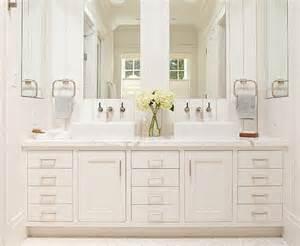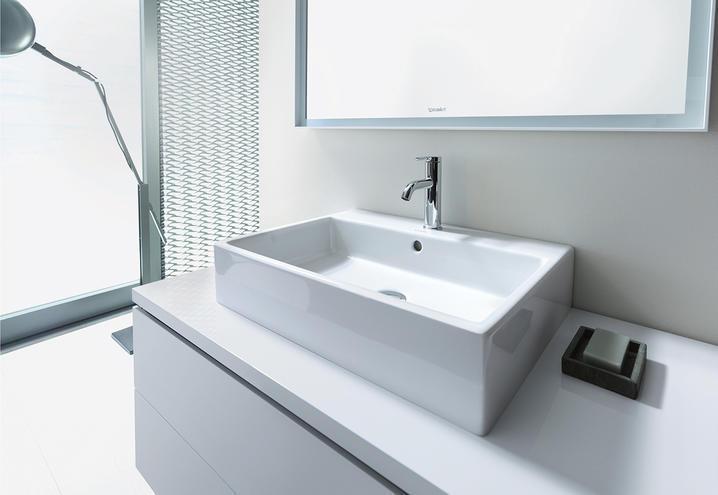The first image is the image on the left, the second image is the image on the right. Examine the images to the left and right. Is the description "In the image to the right, we have a bathtub." accurate? Answer yes or no. No. 